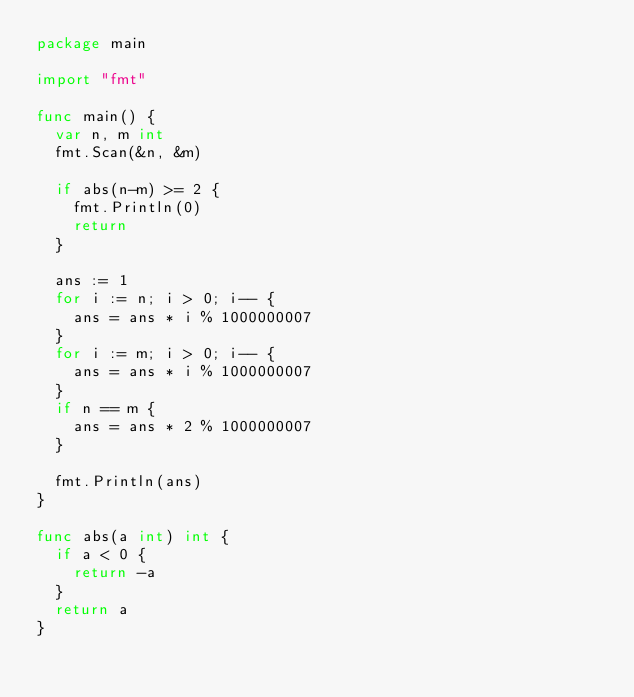<code> <loc_0><loc_0><loc_500><loc_500><_Go_>package main

import "fmt"

func main() {
	var n, m int
	fmt.Scan(&n, &m)

	if abs(n-m) >= 2 {
		fmt.Println(0)
		return
	}

	ans := 1
	for i := n; i > 0; i-- {
		ans = ans * i % 1000000007
	}
	for i := m; i > 0; i-- {
		ans = ans * i % 1000000007
	}
	if n == m {
		ans = ans * 2 % 1000000007
	}

	fmt.Println(ans)
}

func abs(a int) int {
	if a < 0 {
		return -a
	}
	return a
}
</code> 